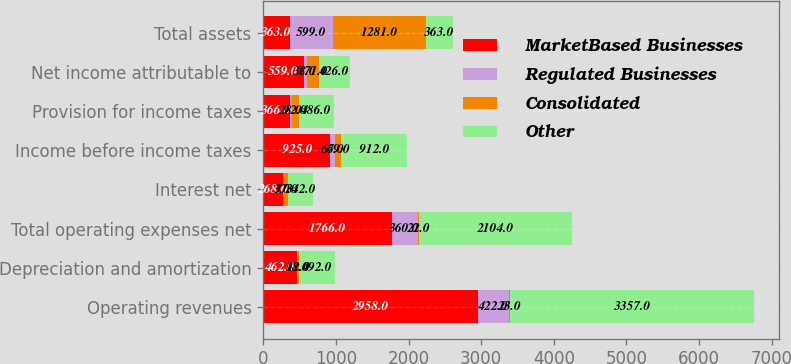<chart> <loc_0><loc_0><loc_500><loc_500><stacked_bar_chart><ecel><fcel>Operating revenues<fcel>Depreciation and amortization<fcel>Total operating expenses net<fcel>Interest net<fcel>Income before income taxes<fcel>Provision for income taxes<fcel>Net income attributable to<fcel>Total assets<nl><fcel>MarketBased Businesses<fcel>2958<fcel>462<fcel>1766<fcel>268<fcel>925<fcel>366<fcel>559<fcel>363<nl><fcel>Regulated Businesses<fcel>422<fcel>18<fcel>360<fcel>3<fcel>66<fcel>28<fcel>38<fcel>599<nl><fcel>Consolidated<fcel>23<fcel>12<fcel>22<fcel>77<fcel>79<fcel>92<fcel>171<fcel>1281<nl><fcel>Other<fcel>3357<fcel>492<fcel>2104<fcel>342<fcel>912<fcel>486<fcel>426<fcel>363<nl></chart> 